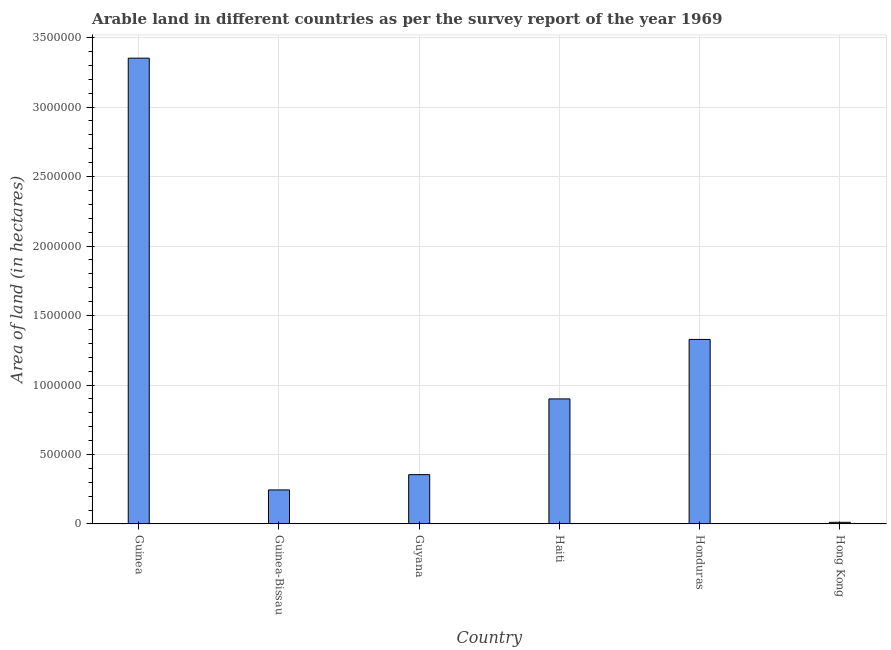What is the title of the graph?
Make the answer very short. Arable land in different countries as per the survey report of the year 1969. What is the label or title of the Y-axis?
Make the answer very short. Area of land (in hectares). What is the area of land in Haiti?
Provide a succinct answer. 9.00e+05. Across all countries, what is the maximum area of land?
Offer a terse response. 3.35e+06. Across all countries, what is the minimum area of land?
Keep it short and to the point. 1.20e+04. In which country was the area of land maximum?
Your answer should be compact. Guinea. In which country was the area of land minimum?
Offer a very short reply. Hong Kong. What is the sum of the area of land?
Provide a succinct answer. 6.19e+06. What is the difference between the area of land in Guyana and Hong Kong?
Keep it short and to the point. 3.43e+05. What is the average area of land per country?
Provide a short and direct response. 1.03e+06. What is the median area of land?
Make the answer very short. 6.28e+05. What is the ratio of the area of land in Guinea-Bissau to that in Guyana?
Give a very brief answer. 0.69. Is the area of land in Guinea-Bissau less than that in Guyana?
Offer a terse response. Yes. Is the difference between the area of land in Honduras and Hong Kong greater than the difference between any two countries?
Offer a terse response. No. What is the difference between the highest and the second highest area of land?
Provide a short and direct response. 2.02e+06. What is the difference between the highest and the lowest area of land?
Give a very brief answer. 3.34e+06. In how many countries, is the area of land greater than the average area of land taken over all countries?
Your response must be concise. 2. How many bars are there?
Keep it short and to the point. 6. Are all the bars in the graph horizontal?
Keep it short and to the point. No. What is the Area of land (in hectares) of Guinea?
Your answer should be compact. 3.35e+06. What is the Area of land (in hectares) of Guinea-Bissau?
Ensure brevity in your answer.  2.45e+05. What is the Area of land (in hectares) in Guyana?
Offer a terse response. 3.55e+05. What is the Area of land (in hectares) in Haiti?
Your answer should be very brief. 9.00e+05. What is the Area of land (in hectares) of Honduras?
Your answer should be very brief. 1.33e+06. What is the Area of land (in hectares) of Hong Kong?
Ensure brevity in your answer.  1.20e+04. What is the difference between the Area of land (in hectares) in Guinea and Guinea-Bissau?
Make the answer very short. 3.11e+06. What is the difference between the Area of land (in hectares) in Guinea and Guyana?
Make the answer very short. 3.00e+06. What is the difference between the Area of land (in hectares) in Guinea and Haiti?
Give a very brief answer. 2.45e+06. What is the difference between the Area of land (in hectares) in Guinea and Honduras?
Provide a succinct answer. 2.02e+06. What is the difference between the Area of land (in hectares) in Guinea and Hong Kong?
Your answer should be compact. 3.34e+06. What is the difference between the Area of land (in hectares) in Guinea-Bissau and Guyana?
Keep it short and to the point. -1.10e+05. What is the difference between the Area of land (in hectares) in Guinea-Bissau and Haiti?
Give a very brief answer. -6.55e+05. What is the difference between the Area of land (in hectares) in Guinea-Bissau and Honduras?
Offer a terse response. -1.08e+06. What is the difference between the Area of land (in hectares) in Guinea-Bissau and Hong Kong?
Make the answer very short. 2.33e+05. What is the difference between the Area of land (in hectares) in Guyana and Haiti?
Offer a terse response. -5.45e+05. What is the difference between the Area of land (in hectares) in Guyana and Honduras?
Provide a short and direct response. -9.73e+05. What is the difference between the Area of land (in hectares) in Guyana and Hong Kong?
Your answer should be very brief. 3.43e+05. What is the difference between the Area of land (in hectares) in Haiti and Honduras?
Offer a very short reply. -4.28e+05. What is the difference between the Area of land (in hectares) in Haiti and Hong Kong?
Make the answer very short. 8.88e+05. What is the difference between the Area of land (in hectares) in Honduras and Hong Kong?
Ensure brevity in your answer.  1.32e+06. What is the ratio of the Area of land (in hectares) in Guinea to that in Guinea-Bissau?
Your answer should be very brief. 13.68. What is the ratio of the Area of land (in hectares) in Guinea to that in Guyana?
Provide a succinct answer. 9.44. What is the ratio of the Area of land (in hectares) in Guinea to that in Haiti?
Keep it short and to the point. 3.72. What is the ratio of the Area of land (in hectares) in Guinea to that in Honduras?
Give a very brief answer. 2.52. What is the ratio of the Area of land (in hectares) in Guinea to that in Hong Kong?
Make the answer very short. 279.33. What is the ratio of the Area of land (in hectares) in Guinea-Bissau to that in Guyana?
Offer a very short reply. 0.69. What is the ratio of the Area of land (in hectares) in Guinea-Bissau to that in Haiti?
Keep it short and to the point. 0.27. What is the ratio of the Area of land (in hectares) in Guinea-Bissau to that in Honduras?
Offer a terse response. 0.18. What is the ratio of the Area of land (in hectares) in Guinea-Bissau to that in Hong Kong?
Provide a short and direct response. 20.42. What is the ratio of the Area of land (in hectares) in Guyana to that in Haiti?
Offer a very short reply. 0.39. What is the ratio of the Area of land (in hectares) in Guyana to that in Honduras?
Offer a terse response. 0.27. What is the ratio of the Area of land (in hectares) in Guyana to that in Hong Kong?
Offer a terse response. 29.58. What is the ratio of the Area of land (in hectares) in Haiti to that in Honduras?
Ensure brevity in your answer.  0.68. What is the ratio of the Area of land (in hectares) in Haiti to that in Hong Kong?
Your answer should be very brief. 75. What is the ratio of the Area of land (in hectares) in Honduras to that in Hong Kong?
Offer a terse response. 110.67. 